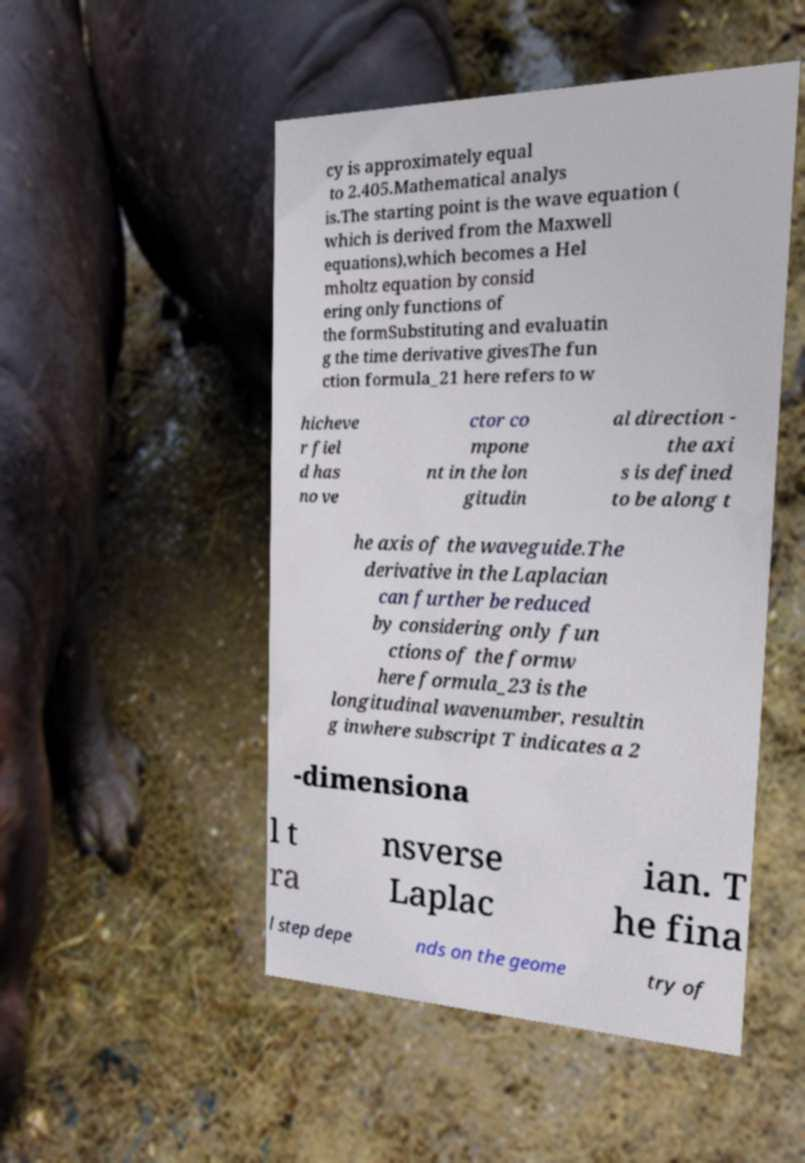There's text embedded in this image that I need extracted. Can you transcribe it verbatim? cy is approximately equal to 2.405.Mathematical analys is.The starting point is the wave equation ( which is derived from the Maxwell equations),which becomes a Hel mholtz equation by consid ering only functions of the formSubstituting and evaluatin g the time derivative givesThe fun ction formula_21 here refers to w hicheve r fiel d has no ve ctor co mpone nt in the lon gitudin al direction - the axi s is defined to be along t he axis of the waveguide.The derivative in the Laplacian can further be reduced by considering only fun ctions of the formw here formula_23 is the longitudinal wavenumber, resultin g inwhere subscript T indicates a 2 -dimensiona l t ra nsverse Laplac ian. T he fina l step depe nds on the geome try of 